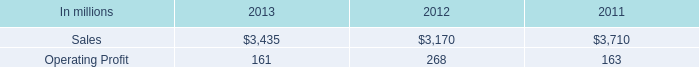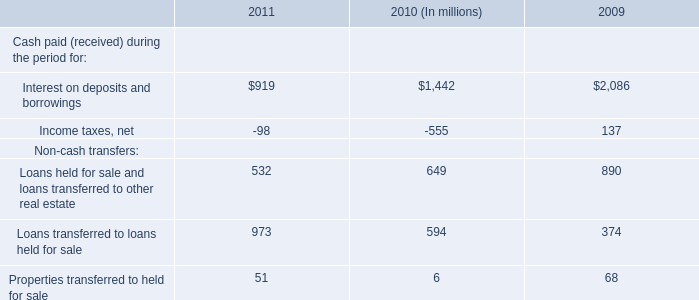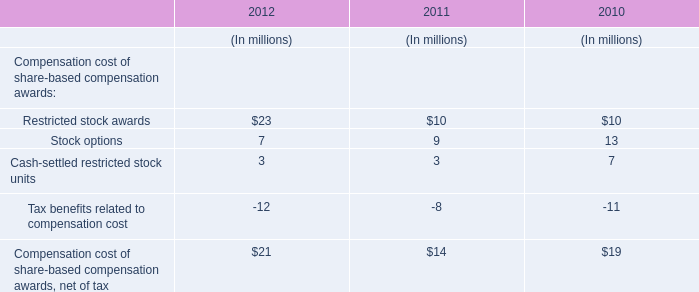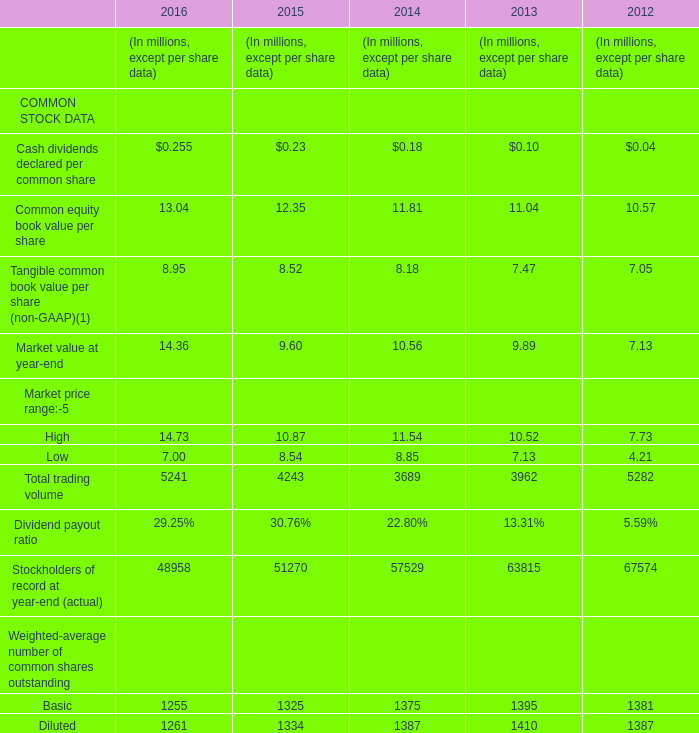Which year is Cash dividends declared per common share the highest? 
Answer: 2016. 